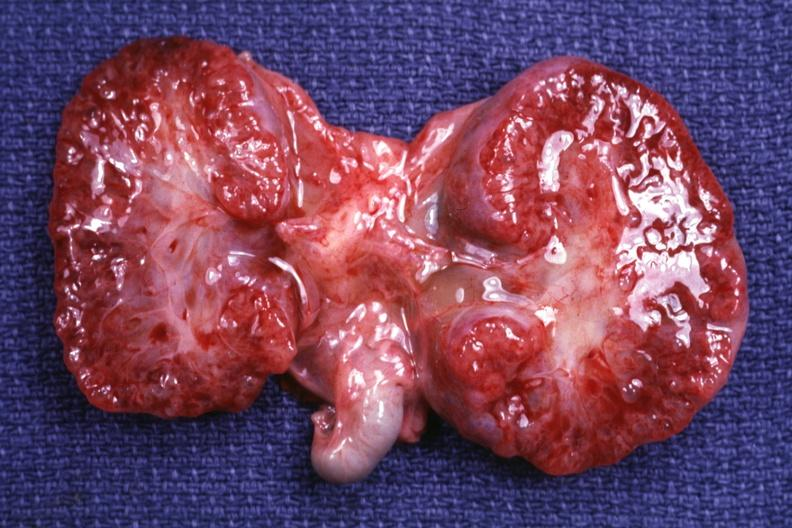s acute lymphocytic leukemia present?
Answer the question using a single word or phrase. No 